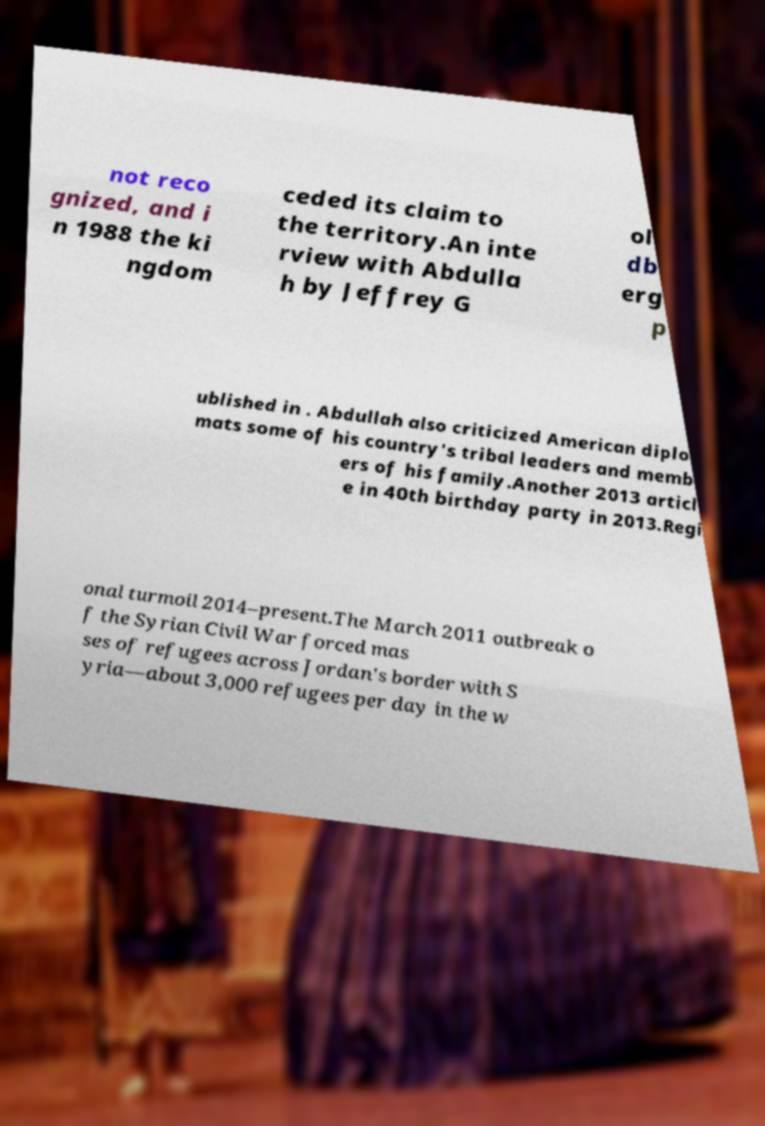What messages or text are displayed in this image? I need them in a readable, typed format. not reco gnized, and i n 1988 the ki ngdom ceded its claim to the territory.An inte rview with Abdulla h by Jeffrey G ol db erg p ublished in . Abdullah also criticized American diplo mats some of his country's tribal leaders and memb ers of his family.Another 2013 articl e in 40th birthday party in 2013.Regi onal turmoil 2014–present.The March 2011 outbreak o f the Syrian Civil War forced mas ses of refugees across Jordan's border with S yria—about 3,000 refugees per day in the w 